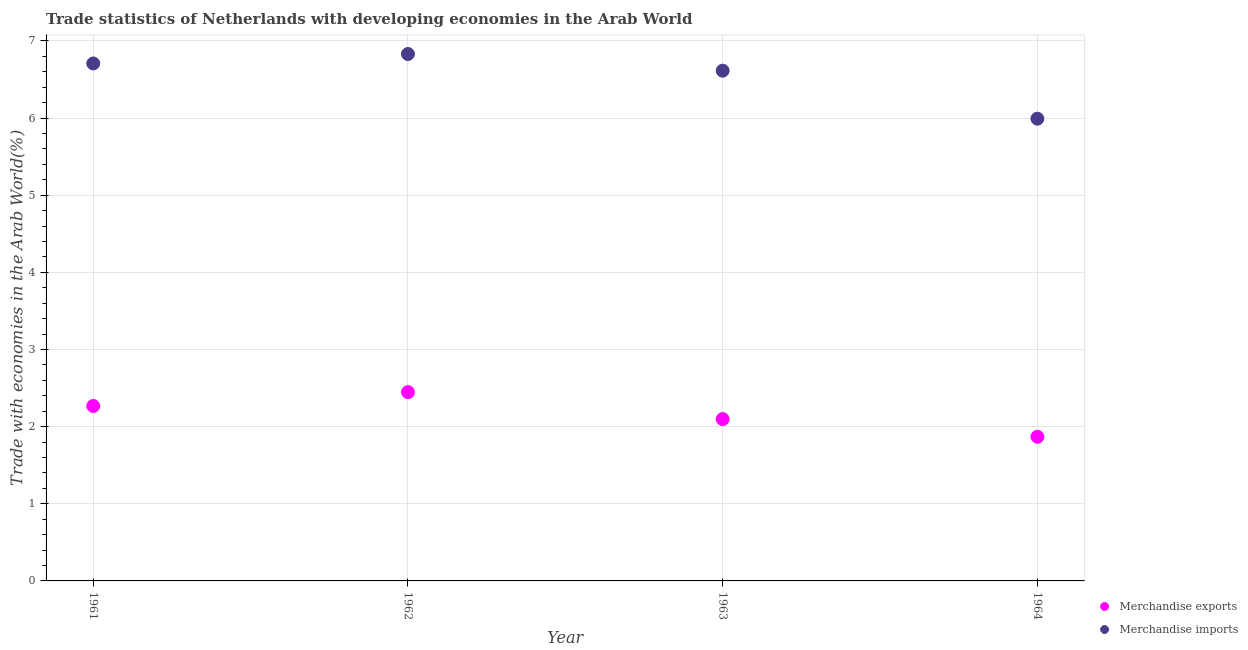What is the merchandise exports in 1964?
Give a very brief answer. 1.87. Across all years, what is the maximum merchandise imports?
Provide a succinct answer. 6.83. Across all years, what is the minimum merchandise imports?
Make the answer very short. 5.99. In which year was the merchandise imports maximum?
Ensure brevity in your answer.  1962. In which year was the merchandise exports minimum?
Make the answer very short. 1964. What is the total merchandise exports in the graph?
Ensure brevity in your answer.  8.68. What is the difference between the merchandise imports in 1962 and that in 1964?
Offer a very short reply. 0.84. What is the difference between the merchandise exports in 1962 and the merchandise imports in 1964?
Your response must be concise. -3.54. What is the average merchandise exports per year?
Give a very brief answer. 2.17. In the year 1963, what is the difference between the merchandise exports and merchandise imports?
Offer a terse response. -4.52. What is the ratio of the merchandise imports in 1961 to that in 1962?
Provide a succinct answer. 0.98. Is the merchandise exports in 1961 less than that in 1962?
Your response must be concise. Yes. What is the difference between the highest and the second highest merchandise exports?
Ensure brevity in your answer.  0.18. What is the difference between the highest and the lowest merchandise exports?
Your answer should be very brief. 0.58. Is the sum of the merchandise imports in 1962 and 1963 greater than the maximum merchandise exports across all years?
Give a very brief answer. Yes. Does the merchandise exports monotonically increase over the years?
Offer a very short reply. No. Is the merchandise exports strictly greater than the merchandise imports over the years?
Your answer should be compact. No. Is the merchandise exports strictly less than the merchandise imports over the years?
Your answer should be very brief. Yes. How many dotlines are there?
Your answer should be compact. 2. Are the values on the major ticks of Y-axis written in scientific E-notation?
Your response must be concise. No. Does the graph contain grids?
Your answer should be compact. Yes. Where does the legend appear in the graph?
Make the answer very short. Bottom right. How many legend labels are there?
Keep it short and to the point. 2. What is the title of the graph?
Offer a very short reply. Trade statistics of Netherlands with developing economies in the Arab World. What is the label or title of the Y-axis?
Provide a succinct answer. Trade with economies in the Arab World(%). What is the Trade with economies in the Arab World(%) of Merchandise exports in 1961?
Offer a very short reply. 2.27. What is the Trade with economies in the Arab World(%) in Merchandise imports in 1961?
Make the answer very short. 6.71. What is the Trade with economies in the Arab World(%) of Merchandise exports in 1962?
Make the answer very short. 2.45. What is the Trade with economies in the Arab World(%) of Merchandise imports in 1962?
Your response must be concise. 6.83. What is the Trade with economies in the Arab World(%) of Merchandise exports in 1963?
Your response must be concise. 2.1. What is the Trade with economies in the Arab World(%) of Merchandise imports in 1963?
Provide a succinct answer. 6.61. What is the Trade with economies in the Arab World(%) in Merchandise exports in 1964?
Make the answer very short. 1.87. What is the Trade with economies in the Arab World(%) of Merchandise imports in 1964?
Make the answer very short. 5.99. Across all years, what is the maximum Trade with economies in the Arab World(%) in Merchandise exports?
Provide a succinct answer. 2.45. Across all years, what is the maximum Trade with economies in the Arab World(%) of Merchandise imports?
Provide a succinct answer. 6.83. Across all years, what is the minimum Trade with economies in the Arab World(%) in Merchandise exports?
Offer a terse response. 1.87. Across all years, what is the minimum Trade with economies in the Arab World(%) in Merchandise imports?
Your answer should be compact. 5.99. What is the total Trade with economies in the Arab World(%) in Merchandise exports in the graph?
Your answer should be compact. 8.68. What is the total Trade with economies in the Arab World(%) in Merchandise imports in the graph?
Your answer should be very brief. 26.14. What is the difference between the Trade with economies in the Arab World(%) in Merchandise exports in 1961 and that in 1962?
Ensure brevity in your answer.  -0.18. What is the difference between the Trade with economies in the Arab World(%) in Merchandise imports in 1961 and that in 1962?
Keep it short and to the point. -0.12. What is the difference between the Trade with economies in the Arab World(%) in Merchandise exports in 1961 and that in 1963?
Provide a short and direct response. 0.17. What is the difference between the Trade with economies in the Arab World(%) of Merchandise imports in 1961 and that in 1963?
Make the answer very short. 0.09. What is the difference between the Trade with economies in the Arab World(%) in Merchandise exports in 1961 and that in 1964?
Your answer should be very brief. 0.4. What is the difference between the Trade with economies in the Arab World(%) of Merchandise imports in 1961 and that in 1964?
Your response must be concise. 0.72. What is the difference between the Trade with economies in the Arab World(%) in Merchandise exports in 1962 and that in 1963?
Ensure brevity in your answer.  0.35. What is the difference between the Trade with economies in the Arab World(%) of Merchandise imports in 1962 and that in 1963?
Offer a terse response. 0.22. What is the difference between the Trade with economies in the Arab World(%) of Merchandise exports in 1962 and that in 1964?
Make the answer very short. 0.58. What is the difference between the Trade with economies in the Arab World(%) of Merchandise imports in 1962 and that in 1964?
Make the answer very short. 0.84. What is the difference between the Trade with economies in the Arab World(%) in Merchandise exports in 1963 and that in 1964?
Keep it short and to the point. 0.23. What is the difference between the Trade with economies in the Arab World(%) of Merchandise imports in 1963 and that in 1964?
Give a very brief answer. 0.62. What is the difference between the Trade with economies in the Arab World(%) of Merchandise exports in 1961 and the Trade with economies in the Arab World(%) of Merchandise imports in 1962?
Make the answer very short. -4.56. What is the difference between the Trade with economies in the Arab World(%) of Merchandise exports in 1961 and the Trade with economies in the Arab World(%) of Merchandise imports in 1963?
Your answer should be compact. -4.35. What is the difference between the Trade with economies in the Arab World(%) of Merchandise exports in 1961 and the Trade with economies in the Arab World(%) of Merchandise imports in 1964?
Give a very brief answer. -3.72. What is the difference between the Trade with economies in the Arab World(%) of Merchandise exports in 1962 and the Trade with economies in the Arab World(%) of Merchandise imports in 1963?
Offer a very short reply. -4.17. What is the difference between the Trade with economies in the Arab World(%) in Merchandise exports in 1962 and the Trade with economies in the Arab World(%) in Merchandise imports in 1964?
Provide a short and direct response. -3.54. What is the difference between the Trade with economies in the Arab World(%) of Merchandise exports in 1963 and the Trade with economies in the Arab World(%) of Merchandise imports in 1964?
Your answer should be compact. -3.89. What is the average Trade with economies in the Arab World(%) of Merchandise exports per year?
Your answer should be very brief. 2.17. What is the average Trade with economies in the Arab World(%) of Merchandise imports per year?
Provide a short and direct response. 6.54. In the year 1961, what is the difference between the Trade with economies in the Arab World(%) of Merchandise exports and Trade with economies in the Arab World(%) of Merchandise imports?
Provide a short and direct response. -4.44. In the year 1962, what is the difference between the Trade with economies in the Arab World(%) of Merchandise exports and Trade with economies in the Arab World(%) of Merchandise imports?
Keep it short and to the point. -4.38. In the year 1963, what is the difference between the Trade with economies in the Arab World(%) of Merchandise exports and Trade with economies in the Arab World(%) of Merchandise imports?
Your answer should be very brief. -4.52. In the year 1964, what is the difference between the Trade with economies in the Arab World(%) in Merchandise exports and Trade with economies in the Arab World(%) in Merchandise imports?
Provide a succinct answer. -4.12. What is the ratio of the Trade with economies in the Arab World(%) in Merchandise exports in 1961 to that in 1962?
Your answer should be very brief. 0.93. What is the ratio of the Trade with economies in the Arab World(%) of Merchandise imports in 1961 to that in 1962?
Offer a very short reply. 0.98. What is the ratio of the Trade with economies in the Arab World(%) in Merchandise exports in 1961 to that in 1963?
Ensure brevity in your answer.  1.08. What is the ratio of the Trade with economies in the Arab World(%) in Merchandise imports in 1961 to that in 1963?
Your response must be concise. 1.01. What is the ratio of the Trade with economies in the Arab World(%) of Merchandise exports in 1961 to that in 1964?
Your answer should be compact. 1.21. What is the ratio of the Trade with economies in the Arab World(%) of Merchandise imports in 1961 to that in 1964?
Give a very brief answer. 1.12. What is the ratio of the Trade with economies in the Arab World(%) of Merchandise exports in 1962 to that in 1963?
Give a very brief answer. 1.17. What is the ratio of the Trade with economies in the Arab World(%) in Merchandise imports in 1962 to that in 1963?
Your answer should be very brief. 1.03. What is the ratio of the Trade with economies in the Arab World(%) of Merchandise exports in 1962 to that in 1964?
Give a very brief answer. 1.31. What is the ratio of the Trade with economies in the Arab World(%) of Merchandise imports in 1962 to that in 1964?
Offer a very short reply. 1.14. What is the ratio of the Trade with economies in the Arab World(%) of Merchandise exports in 1963 to that in 1964?
Your answer should be very brief. 1.12. What is the ratio of the Trade with economies in the Arab World(%) of Merchandise imports in 1963 to that in 1964?
Keep it short and to the point. 1.1. What is the difference between the highest and the second highest Trade with economies in the Arab World(%) in Merchandise exports?
Make the answer very short. 0.18. What is the difference between the highest and the second highest Trade with economies in the Arab World(%) of Merchandise imports?
Provide a succinct answer. 0.12. What is the difference between the highest and the lowest Trade with economies in the Arab World(%) of Merchandise exports?
Offer a terse response. 0.58. What is the difference between the highest and the lowest Trade with economies in the Arab World(%) of Merchandise imports?
Ensure brevity in your answer.  0.84. 